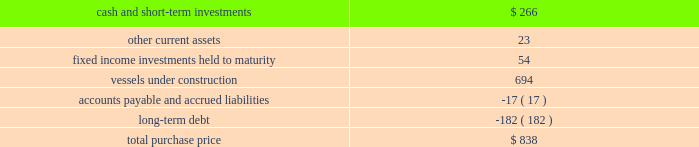Part ii , item 8 fourth quarter of 2007 : 0160 schlumberger sold certain workover rigs for $ 32 million , resulting in a pretax gain of $ 24 million ( $ 17 million after-tax ) which is classified in interest and other income , net in the consolidated statement of income .
Acquisitions acquisition of eastern echo holding plc on december 10 , 2007 , schlumberger completed the acquisition of eastern echo holding plc ( 201ceastern echo 201d ) for $ 838 million in cash .
Eastern echo was a dubai-based marine seismic company that did not have any operations at the time of acquisition , but had signed contracts for the construction of six seismic vessels .
The purchase price has been allocated to the net assets acquired based upon their estimated fair values as follows : ( stated in millions ) .
Other acquisitions schlumberger has made other acquisitions and minority interest investments , none of which were significant on an individual basis , for cash payments , net of cash acquired , of $ 514 million during 2009 , $ 345 million during 2008 , and $ 281 million during 2007 .
Pro forma results pertaining to the above acquisitions are not presented as the impact was not significant .
Drilling fluids joint venture the mi-swaco drilling fluids joint venture is owned 40% ( 40 % ) by schlumberger and 60% ( 60 % ) by smith international , inc .
Schlumberger records income relating to this venture using the equity method of accounting .
The carrying value of schlumberger 2019s investment in the joint venture on december 31 , 2009 and 2008 was $ 1.4 billion and $ 1.3 billion , respectively , and is included within investments in affiliated companies on the consolidated balance sheet .
Schlumberger 2019s equity income from this joint venture was $ 131 million in 2009 , $ 210 million in 2008 and $ 178 million in 2007 .
Schlumberger received cash distributions from the joint venture of $ 106 million in 2009 , $ 57 million in 2008 and $ 46 million in 2007 .
The joint venture agreement contains a provision under which either party to the joint venture may offer to sell its entire interest in the venture to the other party at a cash purchase price per percentage interest specified in an offer notice .
If the offer to sell is not accepted , the offering party will be obligated to purchase the entire interest of the other party at the same price per percentage interest as the prices specified in the offer notice. .
What was the growth rate of the equity income in drilling fluids joint venture the mi-swaco from 2007 to 2007 for schlumberger? 
Rationale: the growth rate is the change from one period to the next divided by the original period
Computations: ((210 - 178) / 178)
Answer: 0.17978. 